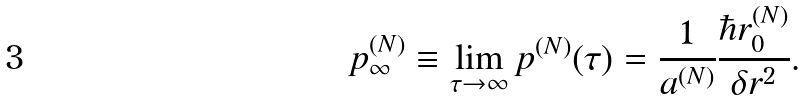Convert formula to latex. <formula><loc_0><loc_0><loc_500><loc_500>p _ { \infty } ^ { ( N ) } \equiv \lim _ { \tau \rightarrow \infty } p ^ { ( N ) } ( \tau ) = \frac { 1 } { a ^ { ( N ) } } \frac { \hbar { r } _ { 0 } ^ { ( N ) } } { \delta r ^ { 2 } } .</formula> 